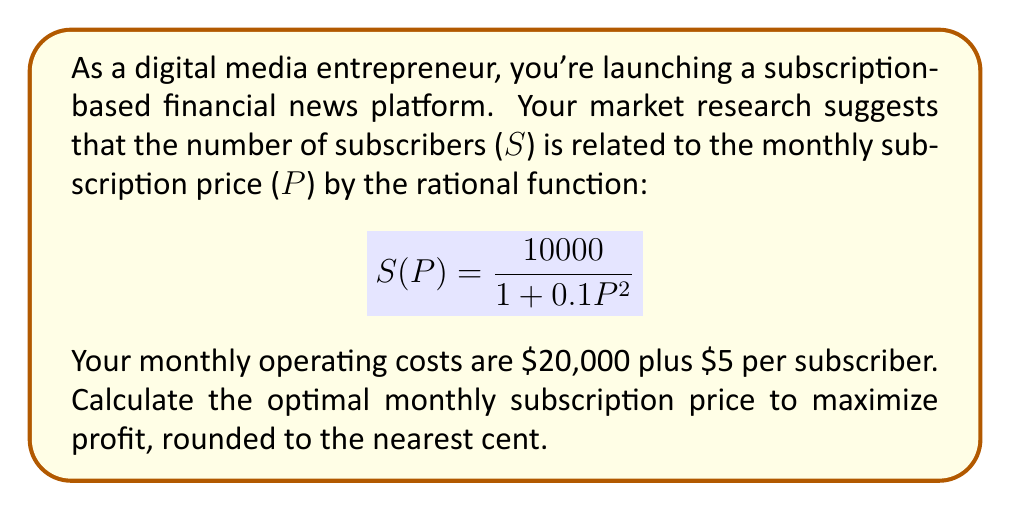What is the answer to this math problem? Let's approach this step-by-step:

1) First, we need to formulate the profit function. Profit is revenue minus costs:

   $$\text{Profit} = \text{Revenue} - \text{Costs}$$

2) Revenue is the product of subscribers and price:
   $$\text{Revenue} = S(P) \cdot P = \frac{10000P}{1 + 0.1P^2}$$

3) Costs are $20,000 plus $5 per subscriber:
   $$\text{Costs} = 20000 + 5S(P) = 20000 + \frac{50000}{1 + 0.1P^2}$$

4) Therefore, the profit function is:
   $$\text{Profit}(P) = \frac{10000P}{1 + 0.1P^2} - 20000 - \frac{50000}{1 + 0.1P^2}$$

5) To find the maximum profit, we need to differentiate this function and set it to zero:
   $$\frac{d}{dP}\text{Profit}(P) = \frac{10000(1 + 0.1P^2) - 10000P(0.2P)}{(1 + 0.1P^2)^2} + \frac{50000(0.2P)}{(1 + 0.1P^2)^2} = 0$$

6) Simplifying:
   $$10000 + 1000P^2 - 2000P^2 + 10000P = 0$$
   $$10000 + 10000P - 1000P^2 = 0$$

7) This is a quadratic equation. Solving it:
   $$1000P^2 - 10000P - 10000 = 0$$
   $$P^2 - 10P - 10 = 0$$
   $$(P - 5)^2 = 35$$
   $$P = 5 \pm \sqrt{35}$$

8) Since price can't be negative, we take the positive root:
   $$P = 5 + \sqrt{35} \approx 10.92$$

9) Rounding to the nearest cent gives us $10.92.
Answer: $10.92 